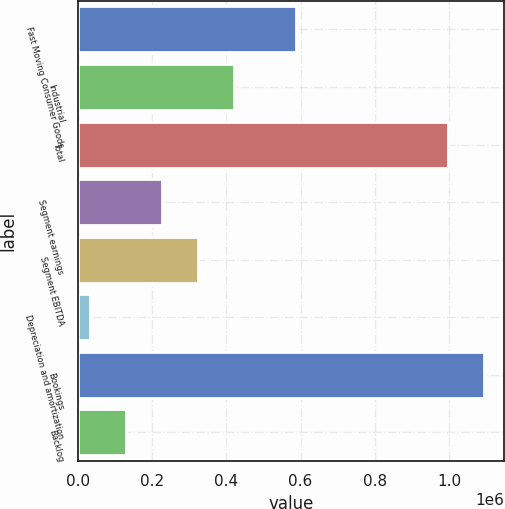Convert chart. <chart><loc_0><loc_0><loc_500><loc_500><bar_chart><fcel>Fast Moving Consumer Goods<fcel>Industrial<fcel>Total<fcel>Segment earnings<fcel>Segment EBITDA<fcel>Depreciation and amortization<fcel>Bookings<fcel>Backlog<nl><fcel>588856<fcel>419783<fcel>996531<fcel>226692<fcel>323238<fcel>33602<fcel>1.09308e+06<fcel>130147<nl></chart> 